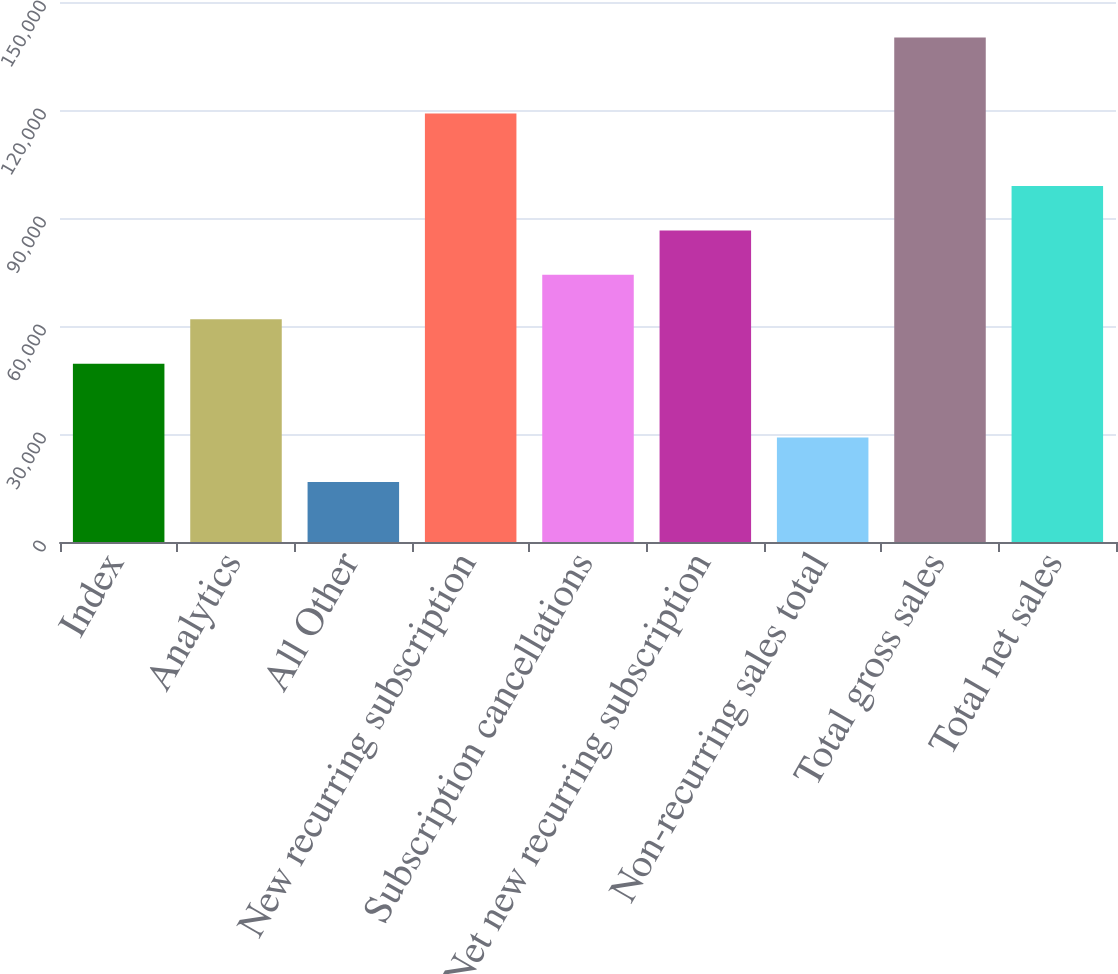Convert chart. <chart><loc_0><loc_0><loc_500><loc_500><bar_chart><fcel>Index<fcel>Analytics<fcel>All Other<fcel>New recurring subscription<fcel>Subscription cancellations<fcel>Net new recurring subscription<fcel>Non-recurring sales total<fcel>Total gross sales<fcel>Total net sales<nl><fcel>49521<fcel>61868<fcel>16657<fcel>118997<fcel>74215<fcel>86562<fcel>29004<fcel>140127<fcel>98909<nl></chart> 